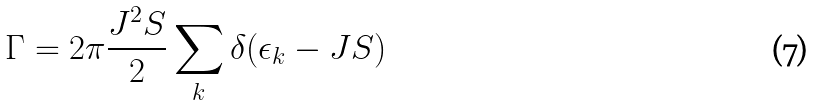Convert formula to latex. <formula><loc_0><loc_0><loc_500><loc_500>\Gamma = 2 \pi \frac { J ^ { 2 } S } { 2 } \sum _ { k } \delta ( \epsilon _ { k } - J S )</formula> 